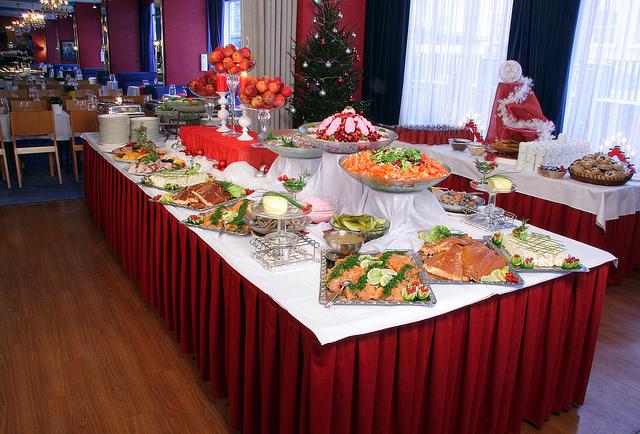Would a person attending this event expect table service?
Concise answer only. No. What color is the table drape?
Give a very brief answer. Red. Are those blueberry muffins on the farthest table?
Keep it brief. Yes. What is the. Color of the room?
Write a very short answer. Red. 